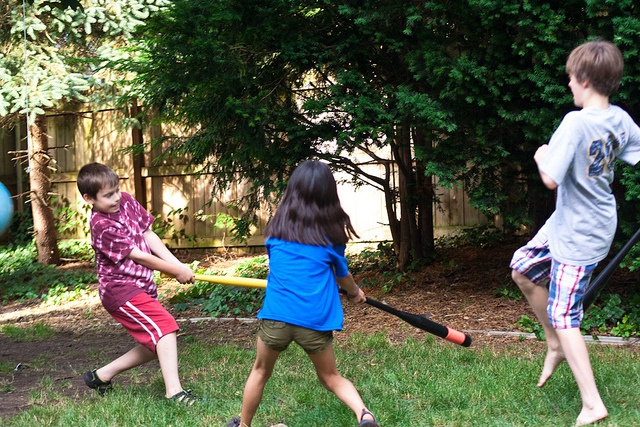Describe the objects in this image and their specific colors. I can see people in black, lavender, darkgray, and gray tones, people in black, lightblue, blue, and gray tones, people in black, lightgray, maroon, brown, and purple tones, baseball bat in black, lightpink, maroon, and salmon tones, and baseball bat in black, gray, and darkblue tones in this image. 